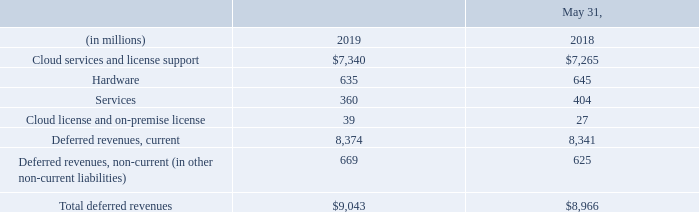9. DEFERRED REVENUES
Deferred revenues consisted of the following:
Deferred cloud services and license support revenues and deferred hardware revenues substantially represent customer payments made in advance for cloud or support contracts that are typically billed in advance with corresponding revenues generally being recognized ratably over the contractual periods. Deferred services revenues include prepayments for our services business and revenues for these services are generally recognized as the services are performed. Deferred cloud license and on-premise license revenues typically resulted from customer payments that related to undelivered products and services or specified enhancements.
In connection with our acquisitions, we have estimated the fair values of the cloud services and license support performance obligations assumed from our acquired companies. We generally have estimated the fair values of these obligations assumed using a cost build-up approach. The cost build-up approach determines fair value by estimating the costs related to fulfilling the obligations plus a normal profit margin. The sum of the costs and operating profit approximates, in theory, the amount that we would be required to pay a third party to assume these acquired obligations. These aforementioned fair value adjustments recorded for obligations assumed from our acquisitions reduced the cloud services and license support deferred revenues balances that we recorded as liabilities from these acquisitions and also reduced the resulting revenues that we recognized or will recognize over the terms of the acquired obligations during the post-combination periods.
How does the cost build-up approach determine fair value? The cost build-up approach determines fair value by estimating the costs related to fulfilling the obligations plus a normal profit margin. When are deferred services revenue recognized? Deferred services revenues include prepayments for our services business and revenues for these services are generally recognized as the services are performed. How did the fair value adjustments recorded for obligations affect the cloud services and license support deferred revenue balances? These aforementioned fair value adjustments recorded for obligations assumed from our acquisitions reduced the cloud services and license support deferred revenues balances that we recorded as liabilities from these acquisitions. What is the current deferred revenue in 2019 as a percentage of total deferred revenue?
Answer scale should be: percent. 8,374/9,043 
Answer: 92.6. What is the average cloud services and license support deferred revenue from 2018 to 2019?
Answer scale should be: million. (7,265+7,340)/2
Answer: 7302.5. What is the difference in the total deferred revenues from 2018 to 2019?
Answer scale should be: million. 9,043-8,966
Answer: 77. 